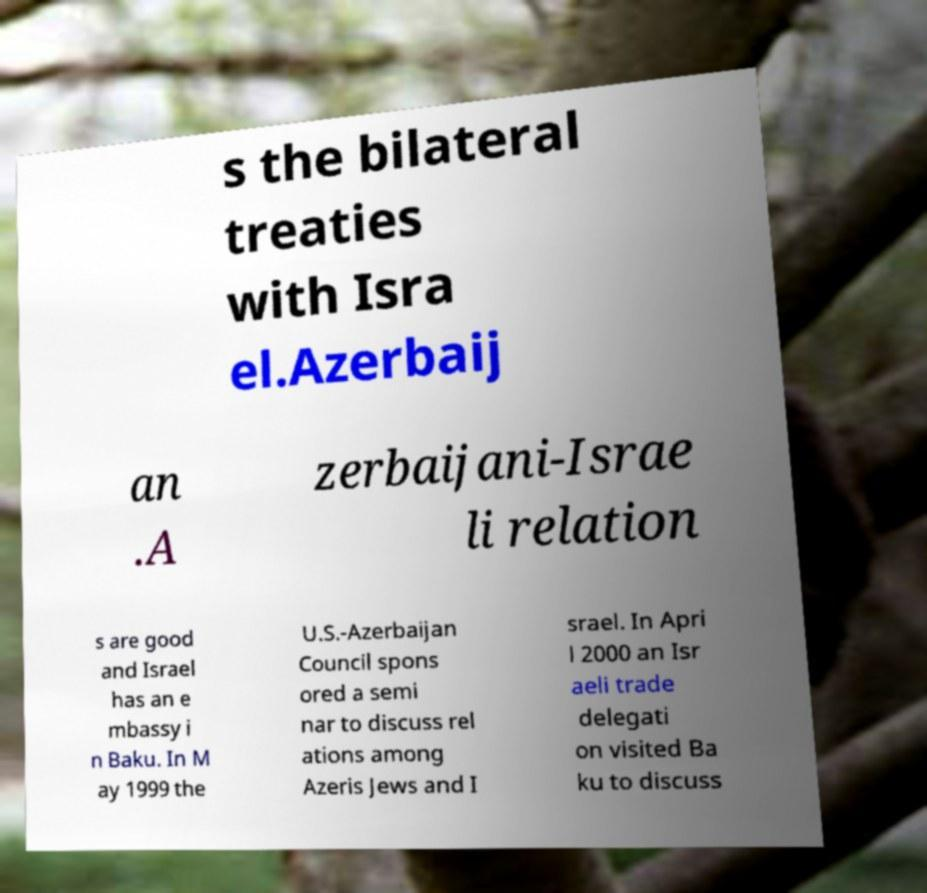Could you assist in decoding the text presented in this image and type it out clearly? s the bilateral treaties with Isra el.Azerbaij an .A zerbaijani-Israe li relation s are good and Israel has an e mbassy i n Baku. In M ay 1999 the U.S.-Azerbaijan Council spons ored a semi nar to discuss rel ations among Azeris Jews and I srael. In Apri l 2000 an Isr aeli trade delegati on visited Ba ku to discuss 